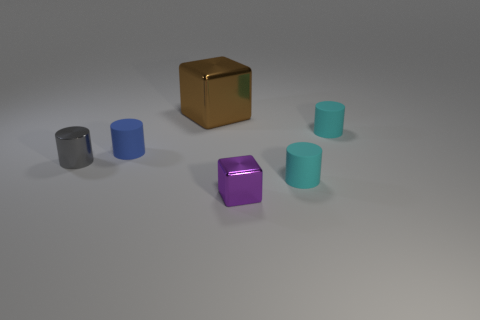Which object stands out the most to you in this image, and why? The shiny purple block stands out the most. Its vibrant color and shiny texture catch the eye immediately, especially against the more subdued colors and matte textures of the surrounding objects. Does the arrangement of these objects suggest any particular pattern or purpose? The objects appear to be arranged with no specific pattern or purpose that can be readily discerned. It seems like a random placement, possibly for an aesthetic display or for illustrating the contrast between shapes, textures, and colors. 